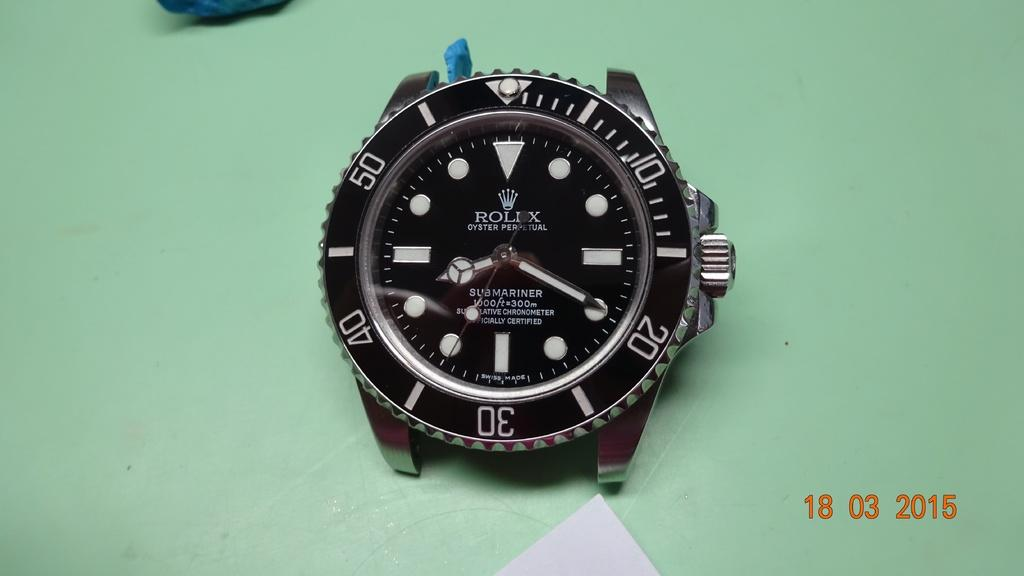Provide a one-sentence caption for the provided image. the face of a mariner watch, without its band. 